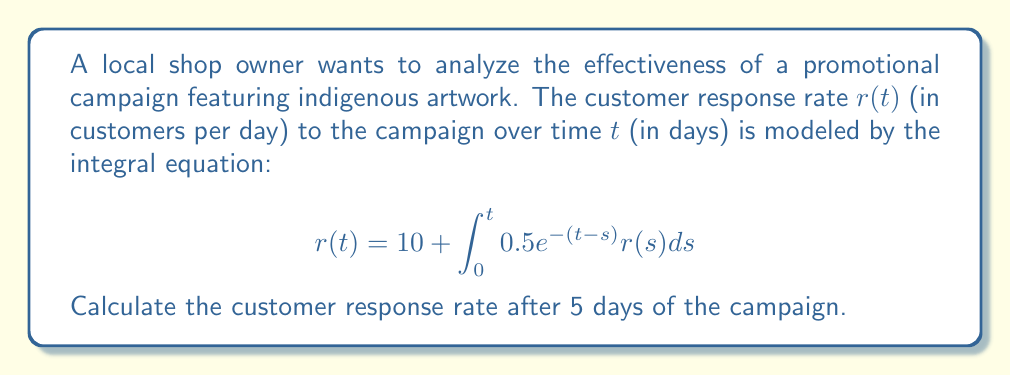Show me your answer to this math problem. To solve this integral equation, we'll use the Laplace transform method:

1) Take the Laplace transform of both sides:
   $$\mathcal{L}\{r(t)\} = \mathcal{L}\{10\} + \mathcal{L}\{\int_0^t 0.5e^{-(t-s)}r(s)ds\}$$

2) Using Laplace transform properties:
   $$R(s) = \frac{10}{s} + 0.5 \cdot \frac{1}{s+1} \cdot R(s)$$
   Where $R(s)$ is the Laplace transform of $r(t)$

3) Solve for $R(s)$:
   $$R(s) = \frac{10}{s} + \frac{0.5R(s)}{s+1}$$
   $$R(s)(1 - \frac{0.5}{s+1}) = \frac{10}{s}$$
   $$R(s) = \frac{10}{s} \cdot \frac{s+1}{s+0.5}$$

4) Partial fraction decomposition:
   $$R(s) = \frac{20}{s} - \frac{10}{s+0.5}$$

5) Take the inverse Laplace transform:
   $$r(t) = 20 - 10e^{-0.5t}$$

6) Evaluate at $t = 5$:
   $$r(5) = 20 - 10e^{-0.5(5)} \approx 16.32$$
Answer: 16.32 customers per day 